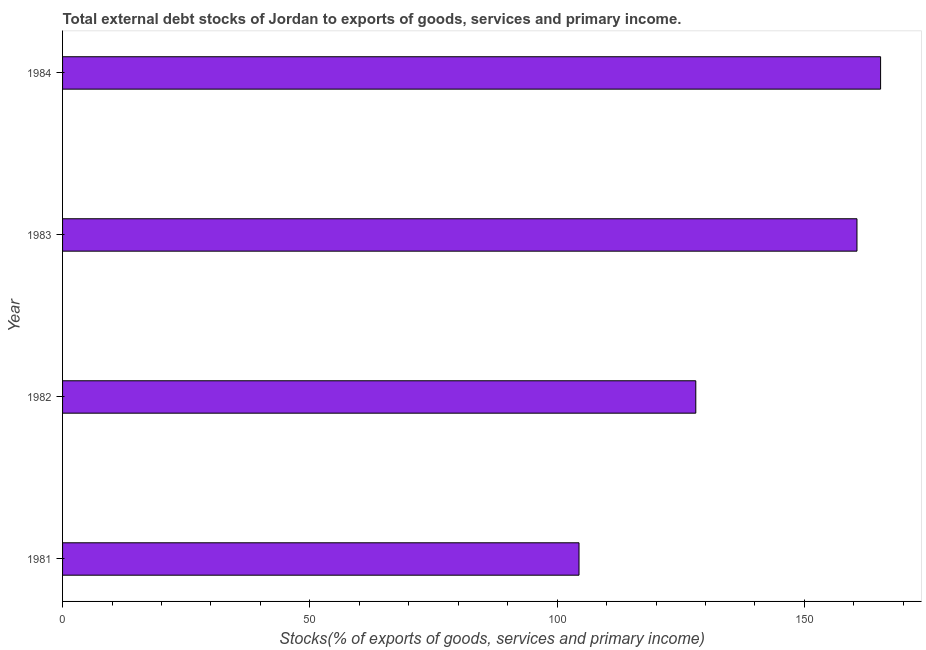Does the graph contain any zero values?
Your answer should be compact. No. Does the graph contain grids?
Your answer should be very brief. No. What is the title of the graph?
Your answer should be very brief. Total external debt stocks of Jordan to exports of goods, services and primary income. What is the label or title of the X-axis?
Offer a terse response. Stocks(% of exports of goods, services and primary income). What is the label or title of the Y-axis?
Keep it short and to the point. Year. What is the external debt stocks in 1982?
Your answer should be compact. 128.04. Across all years, what is the maximum external debt stocks?
Provide a succinct answer. 165.41. Across all years, what is the minimum external debt stocks?
Offer a terse response. 104.43. In which year was the external debt stocks minimum?
Your answer should be very brief. 1981. What is the sum of the external debt stocks?
Keep it short and to the point. 558.52. What is the difference between the external debt stocks in 1982 and 1983?
Your answer should be very brief. -32.59. What is the average external debt stocks per year?
Offer a terse response. 139.63. What is the median external debt stocks?
Offer a very short reply. 144.34. Do a majority of the years between 1982 and 1981 (inclusive) have external debt stocks greater than 110 %?
Provide a succinct answer. No. What is the ratio of the external debt stocks in 1982 to that in 1984?
Keep it short and to the point. 0.77. Is the difference between the external debt stocks in 1981 and 1982 greater than the difference between any two years?
Offer a terse response. No. What is the difference between the highest and the second highest external debt stocks?
Offer a terse response. 4.78. What is the difference between the highest and the lowest external debt stocks?
Offer a terse response. 60.98. In how many years, is the external debt stocks greater than the average external debt stocks taken over all years?
Provide a succinct answer. 2. How many bars are there?
Ensure brevity in your answer.  4. Are all the bars in the graph horizontal?
Your answer should be very brief. Yes. Are the values on the major ticks of X-axis written in scientific E-notation?
Give a very brief answer. No. What is the Stocks(% of exports of goods, services and primary income) in 1981?
Your answer should be very brief. 104.43. What is the Stocks(% of exports of goods, services and primary income) of 1982?
Offer a terse response. 128.04. What is the Stocks(% of exports of goods, services and primary income) of 1983?
Ensure brevity in your answer.  160.63. What is the Stocks(% of exports of goods, services and primary income) in 1984?
Keep it short and to the point. 165.41. What is the difference between the Stocks(% of exports of goods, services and primary income) in 1981 and 1982?
Provide a succinct answer. -23.61. What is the difference between the Stocks(% of exports of goods, services and primary income) in 1981 and 1983?
Offer a terse response. -56.2. What is the difference between the Stocks(% of exports of goods, services and primary income) in 1981 and 1984?
Your answer should be compact. -60.98. What is the difference between the Stocks(% of exports of goods, services and primary income) in 1982 and 1983?
Offer a terse response. -32.59. What is the difference between the Stocks(% of exports of goods, services and primary income) in 1982 and 1984?
Offer a terse response. -37.36. What is the difference between the Stocks(% of exports of goods, services and primary income) in 1983 and 1984?
Keep it short and to the point. -4.78. What is the ratio of the Stocks(% of exports of goods, services and primary income) in 1981 to that in 1982?
Provide a succinct answer. 0.82. What is the ratio of the Stocks(% of exports of goods, services and primary income) in 1981 to that in 1983?
Keep it short and to the point. 0.65. What is the ratio of the Stocks(% of exports of goods, services and primary income) in 1981 to that in 1984?
Offer a terse response. 0.63. What is the ratio of the Stocks(% of exports of goods, services and primary income) in 1982 to that in 1983?
Provide a short and direct response. 0.8. What is the ratio of the Stocks(% of exports of goods, services and primary income) in 1982 to that in 1984?
Offer a very short reply. 0.77. What is the ratio of the Stocks(% of exports of goods, services and primary income) in 1983 to that in 1984?
Provide a succinct answer. 0.97. 